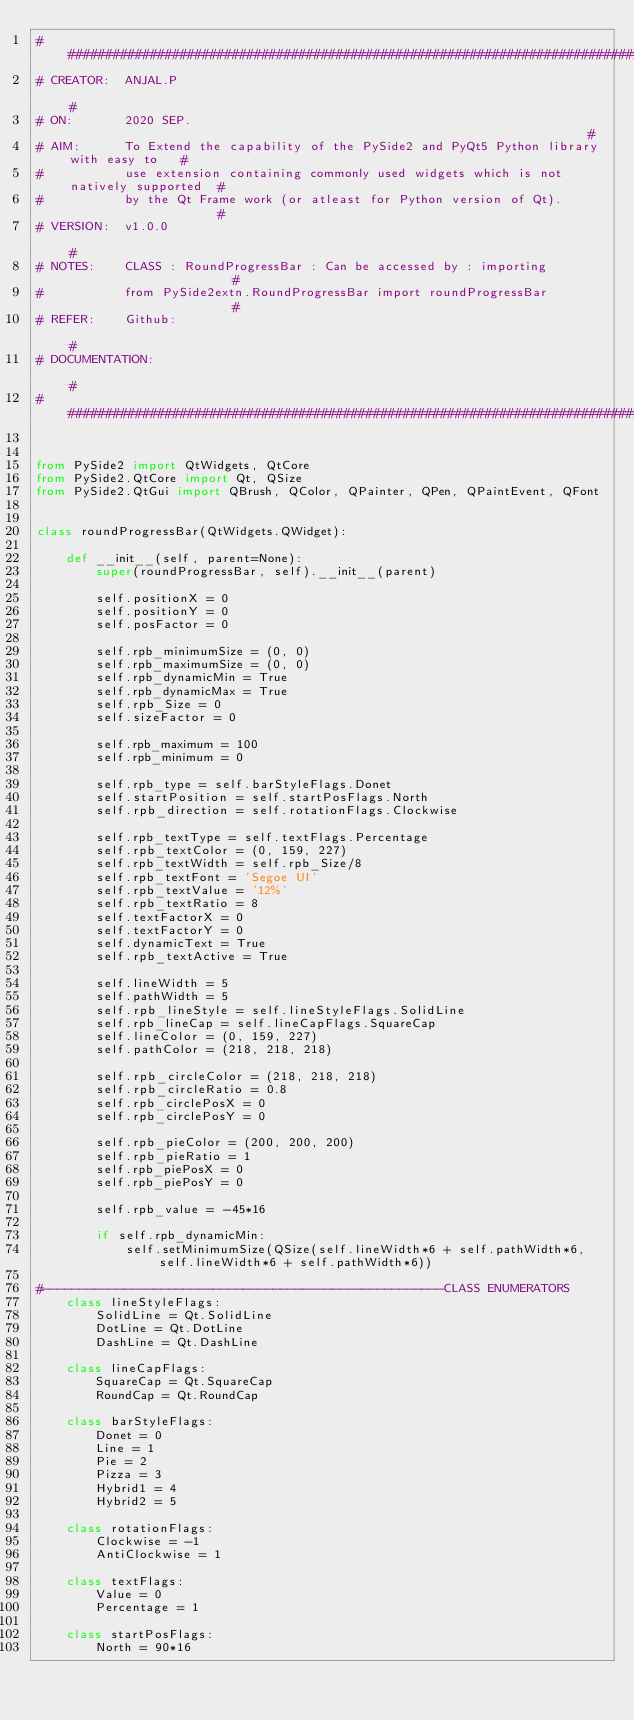Convert code to text. <code><loc_0><loc_0><loc_500><loc_500><_Python_>#############################################################################################
# CREATOR:  ANJAL.P                                                                         #
# ON:       2020 SEP.                                                                       #
# AIM:      To Extend the capability of the PySide2 and PyQt5 Python library with easy to   #
#           use extension containing commonly used widgets which is not natively supported  #
#           by the Qt Frame work (or atleast for Python version of Qt).                     #
# VERSION:  v1.0.0                                                                          #
# NOTES:    CLASS : RoundProgressBar : Can be accessed by : importing                       #
#           from PySide2extn.RoundProgressBar import roundProgressBar                       #
# REFER:    Github:                                                                         #
# DOCUMENTATION:                                                                            #
#############################################################################################


from PySide2 import QtWidgets, QtCore
from PySide2.QtCore import Qt, QSize
from PySide2.QtGui import QBrush, QColor, QPainter, QPen, QPaintEvent, QFont


class roundProgressBar(QtWidgets.QWidget):

    def __init__(self, parent=None):
        super(roundProgressBar, self).__init__(parent)

        self.positionX = 0 
        self.positionY = 0
        self.posFactor = 0

        self.rpb_minimumSize = (0, 0)
        self.rpb_maximumSize = (0, 0)
        self.rpb_dynamicMin = True
        self.rpb_dynamicMax = True
        self.rpb_Size = 0
        self.sizeFactor = 0

        self.rpb_maximum = 100
        self.rpb_minimum = 0

        self.rpb_type = self.barStyleFlags.Donet
        self.startPosition = self.startPosFlags.North
        self.rpb_direction = self.rotationFlags.Clockwise

        self.rpb_textType = self.textFlags.Percentage
        self.rpb_textColor = (0, 159, 227)
        self.rpb_textWidth = self.rpb_Size/8
        self.rpb_textFont = 'Segoe UI'
        self.rpb_textValue = '12%'
        self.rpb_textRatio = 8
        self.textFactorX = 0
        self.textFactorY = 0
        self.dynamicText = True
        self.rpb_textActive = True

        self.lineWidth = 5
        self.pathWidth = 5
        self.rpb_lineStyle = self.lineStyleFlags.SolidLine
        self.rpb_lineCap = self.lineCapFlags.SquareCap
        self.lineColor = (0, 159, 227)
        self.pathColor = (218, 218, 218)

        self.rpb_circleColor = (218, 218, 218)
        self.rpb_circleRatio = 0.8
        self.rpb_circlePosX = 0
        self.rpb_circlePosY = 0

        self.rpb_pieColor = (200, 200, 200)
        self.rpb_pieRatio = 1
        self.rpb_piePosX = 0
        self.rpb_piePosY = 0

        self.rpb_value = -45*16

        if self.rpb_dynamicMin:
            self.setMinimumSize(QSize(self.lineWidth*6 + self.pathWidth*6, self.lineWidth*6 + self.pathWidth*6))

#------------------------------------------------------CLASS ENUMERATORS
    class lineStyleFlags:
        SolidLine = Qt.SolidLine
        DotLine = Qt.DotLine
        DashLine = Qt.DashLine

    class lineCapFlags:
        SquareCap = Qt.SquareCap
        RoundCap = Qt.RoundCap

    class barStyleFlags:
        Donet = 0
        Line = 1
        Pie = 2
        Pizza = 3
        Hybrid1 = 4
        Hybrid2 = 5

    class rotationFlags:
        Clockwise = -1
        AntiClockwise = 1

    class textFlags:
        Value = 0
        Percentage = 1

    class startPosFlags:
        North = 90*16</code> 